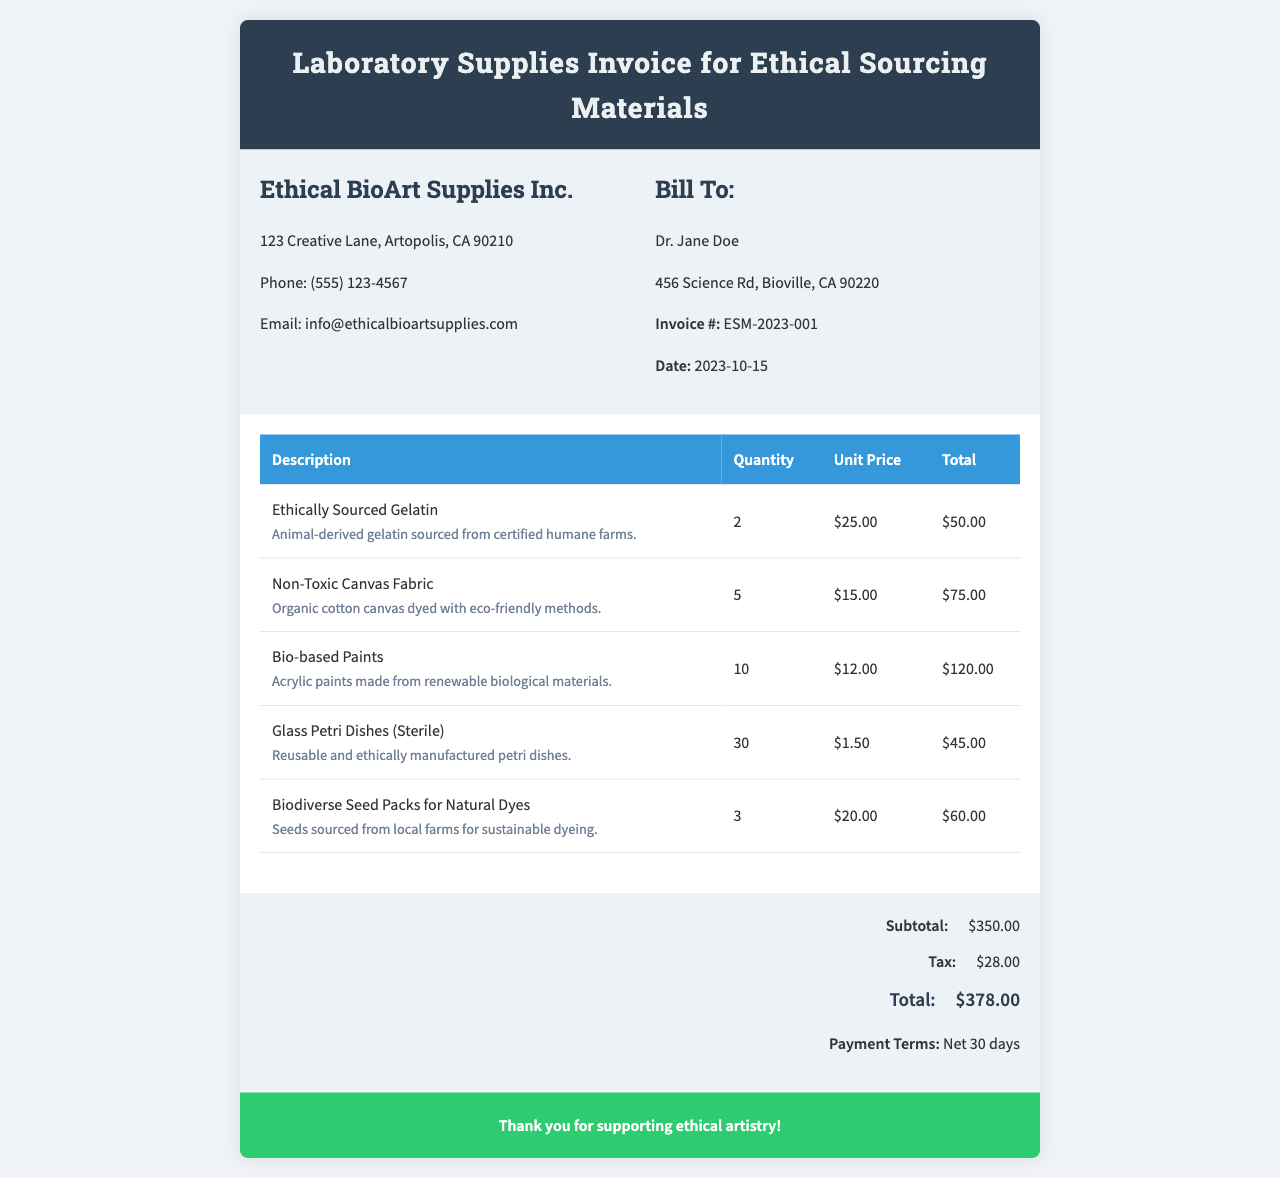What is the total amount due? The total amount due is provided in the invoice summary section.
Answer: $378.00 Who is the invoice issued to? The invoice is issued to Dr. Jane Doe as mentioned in the client info section.
Answer: Dr. Jane Doe What is the date of the invoice? The date of the invoice can be found in the client information section.
Answer: 2023-10-15 How many units of ethically sourced gelatin were ordered? The quantity of ethically sourced gelatin is specified in the invoice item list.
Answer: 2 What is the subtotal of the invoice? The subtotal is listed in the invoice summary before tax is added.
Answer: $350.00 What type of fabric is mentioned in the invoice? The fabric type can be found in the description of one of the items listed.
Answer: Non-Toxic Canvas Fabric What is the contact email for the company? The contact email is provided in the company information section.
Answer: info@ethicalbioartsupplies.com How many glass Petri dishes were purchased? The quantity of glass Petri dishes is specified in the items table.
Answer: 30 